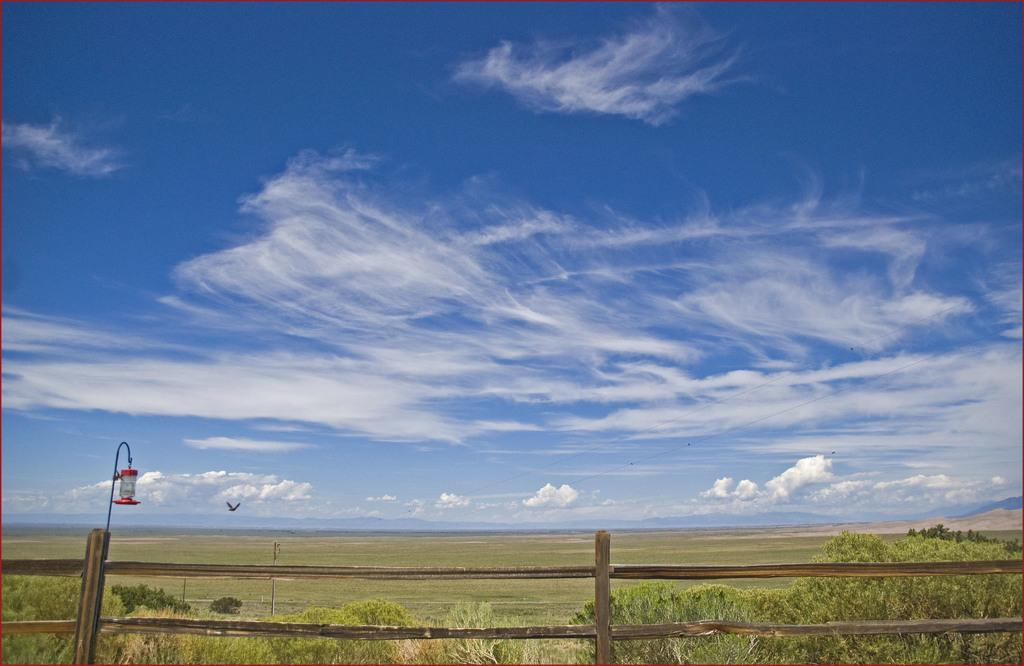What can be seen in the sky in the image? Clouds are present in the image. What type of vegetation is visible in the image? Grass and plants are visible in the image. What is the bird doing in the image? There is a bird flying in the image. What structures are present in the image? Poles and a fence are present in the image. What artificial light source is visible in the image? A lamp is visible in the image. Where is the cactus located in the image? There is no cactus present in the image. What type of coach can be seen driving along the edge of the image? There is no coach or edge present in the image. 